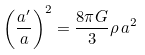<formula> <loc_0><loc_0><loc_500><loc_500>\left ( \frac { a ^ { \prime } } { a } \right ) ^ { 2 } = \frac { 8 \pi G } { 3 } \rho \, a ^ { 2 }</formula> 